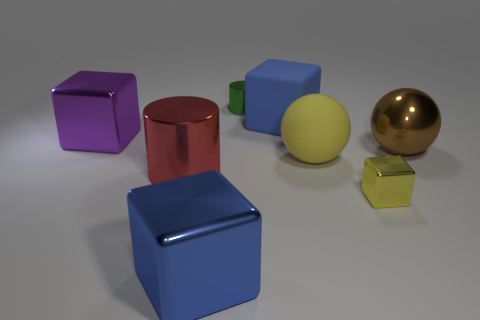What number of blue blocks are made of the same material as the green object?
Make the answer very short. 1. What color is the large block that is made of the same material as the big purple object?
Your answer should be very brief. Blue. Do the shiny block to the right of the large yellow object and the rubber ball have the same color?
Your answer should be very brief. Yes. There is a yellow object behind the yellow metallic object; what is it made of?
Your response must be concise. Rubber. Are there the same number of green metal cylinders that are behind the matte sphere and green cylinders?
Provide a short and direct response. Yes. How many big things have the same color as the tiny shiny cylinder?
Your response must be concise. 0. What color is the other shiny thing that is the same shape as the red metal thing?
Give a very brief answer. Green. Do the blue metal cube and the matte block have the same size?
Give a very brief answer. Yes. Are there the same number of blue matte cubes that are on the left side of the brown shiny ball and tiny green metallic cylinders that are behind the small shiny cylinder?
Give a very brief answer. No. Are there any gray blocks?
Give a very brief answer. No. 